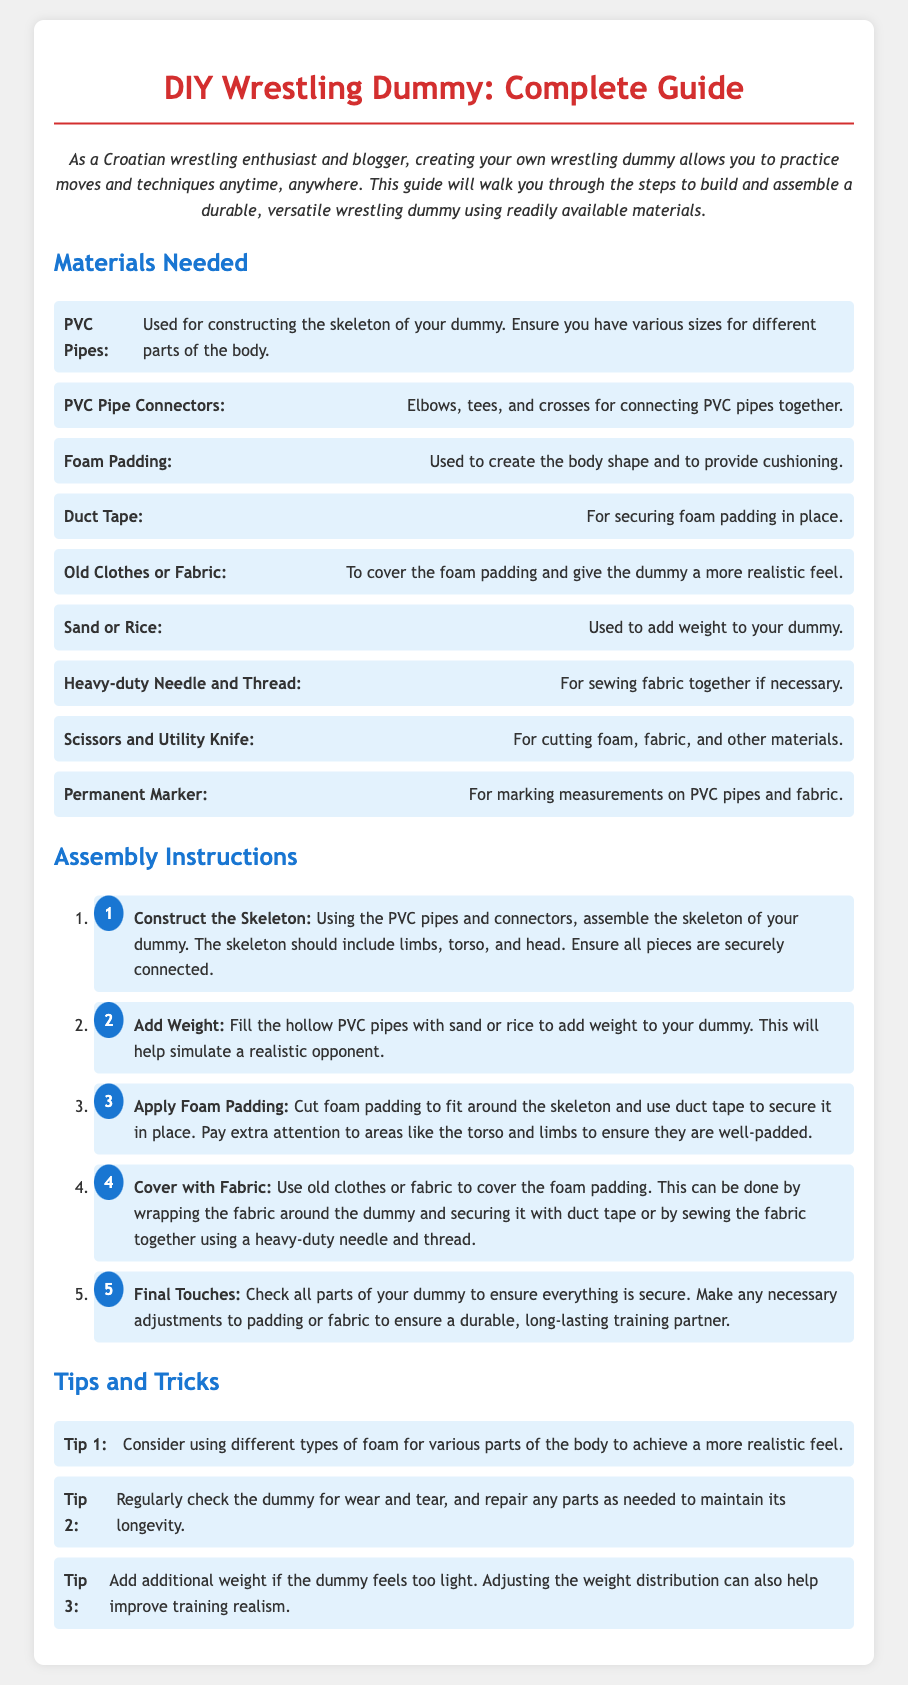What are the main materials needed? The main materials needed are listed in the Materials Needed section, which includes PVC pipes, foam padding, and duct tape among others.
Answer: PVC Pipes, Foam Padding, Duct Tape How many assembly steps are there? The Assembly Instructions section outlines five specific steps for constructing the wrestling dummy.
Answer: 5 What is used to cover the foam padding? The document states that old clothes or fabric are used to cover the foam padding for a realistic feel.
Answer: Old Clothes or Fabric What should be added to the hollow PVC pipes? In the Add Weight step, it specifies that sand or rice should be added to the hollow PVC pipes for weight.
Answer: Sand or Rice Which foam should be used for different parts? The tips suggest using different types of foam for various parts of the body to achieve a more realistic feel.
Answer: Different types of foam What is the purpose of duct tape? Duct tape is used for securing foam padding in place as well as covering the fabric of the dummy.
Answer: Securing foam padding What is the first step in the assembly instructions? The first step outlined in the Assembly Instructions is to construct the skeleton of the dummy using PVC pipes and connectors.
Answer: Construct the Skeleton What tool is necessary for marking measurements? The document mentions that a permanent marker is necessary for marking measurements on PVC pipes and fabric.
Answer: Permanent Marker 